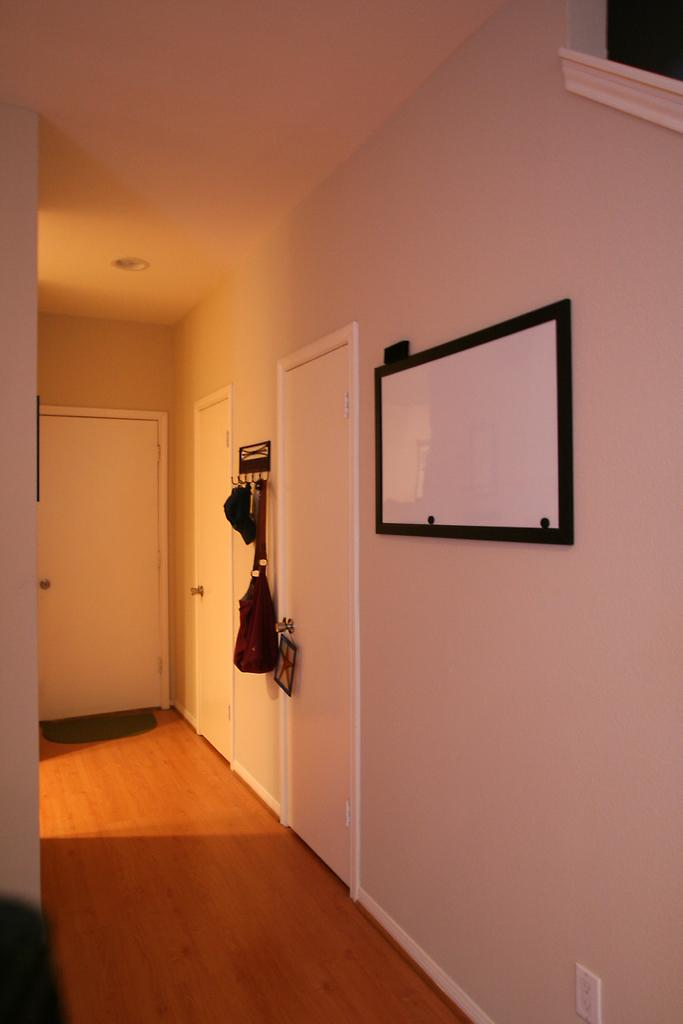What part of a building is depicted in the image? The image shows the inner part of a room. What color are the doors in the room? The doors in the room are in white color. What can be found attached to the wall in the room? There is a frame attached to the wall. What color is the wall in the room? The wall is in cream color. How many daughters are visible in the image? There are no daughters present in the image; it shows the inner part of a room with doors, a frame, and a cream-colored wall. What type of jeans is the person wearing in the image? There are no people or jeans visible in the image. 